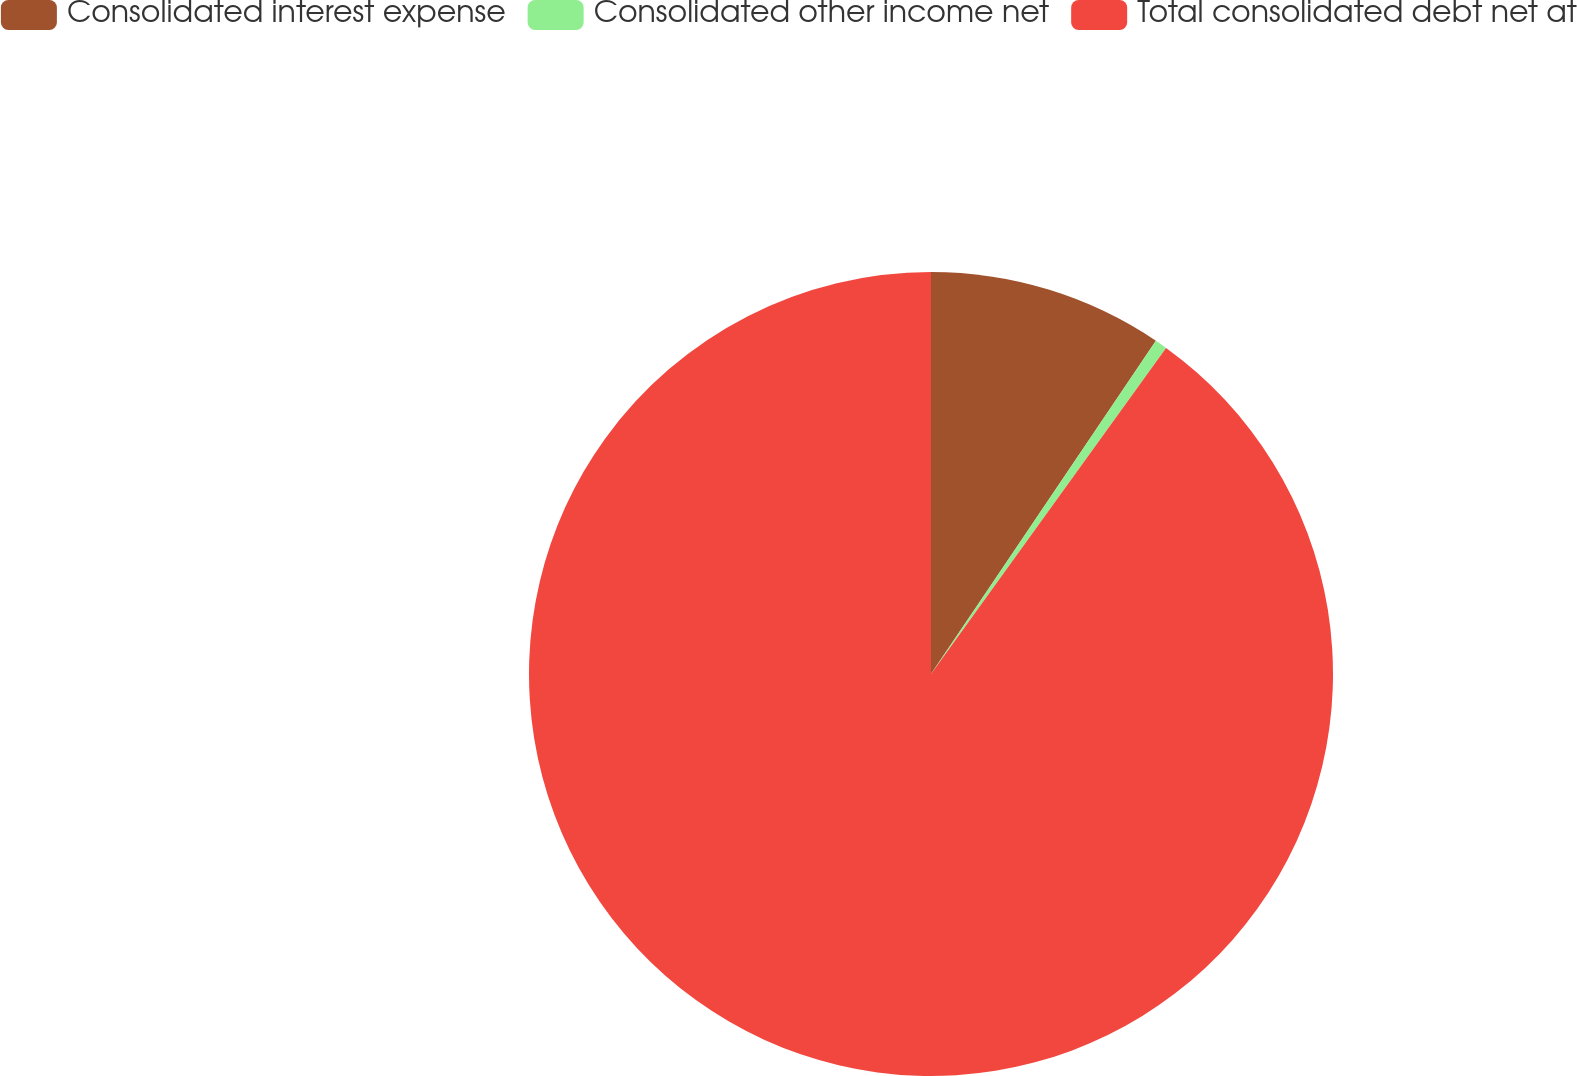Convert chart to OTSL. <chart><loc_0><loc_0><loc_500><loc_500><pie_chart><fcel>Consolidated interest expense<fcel>Consolidated other income net<fcel>Total consolidated debt net at<nl><fcel>9.45%<fcel>0.49%<fcel>90.06%<nl></chart> 